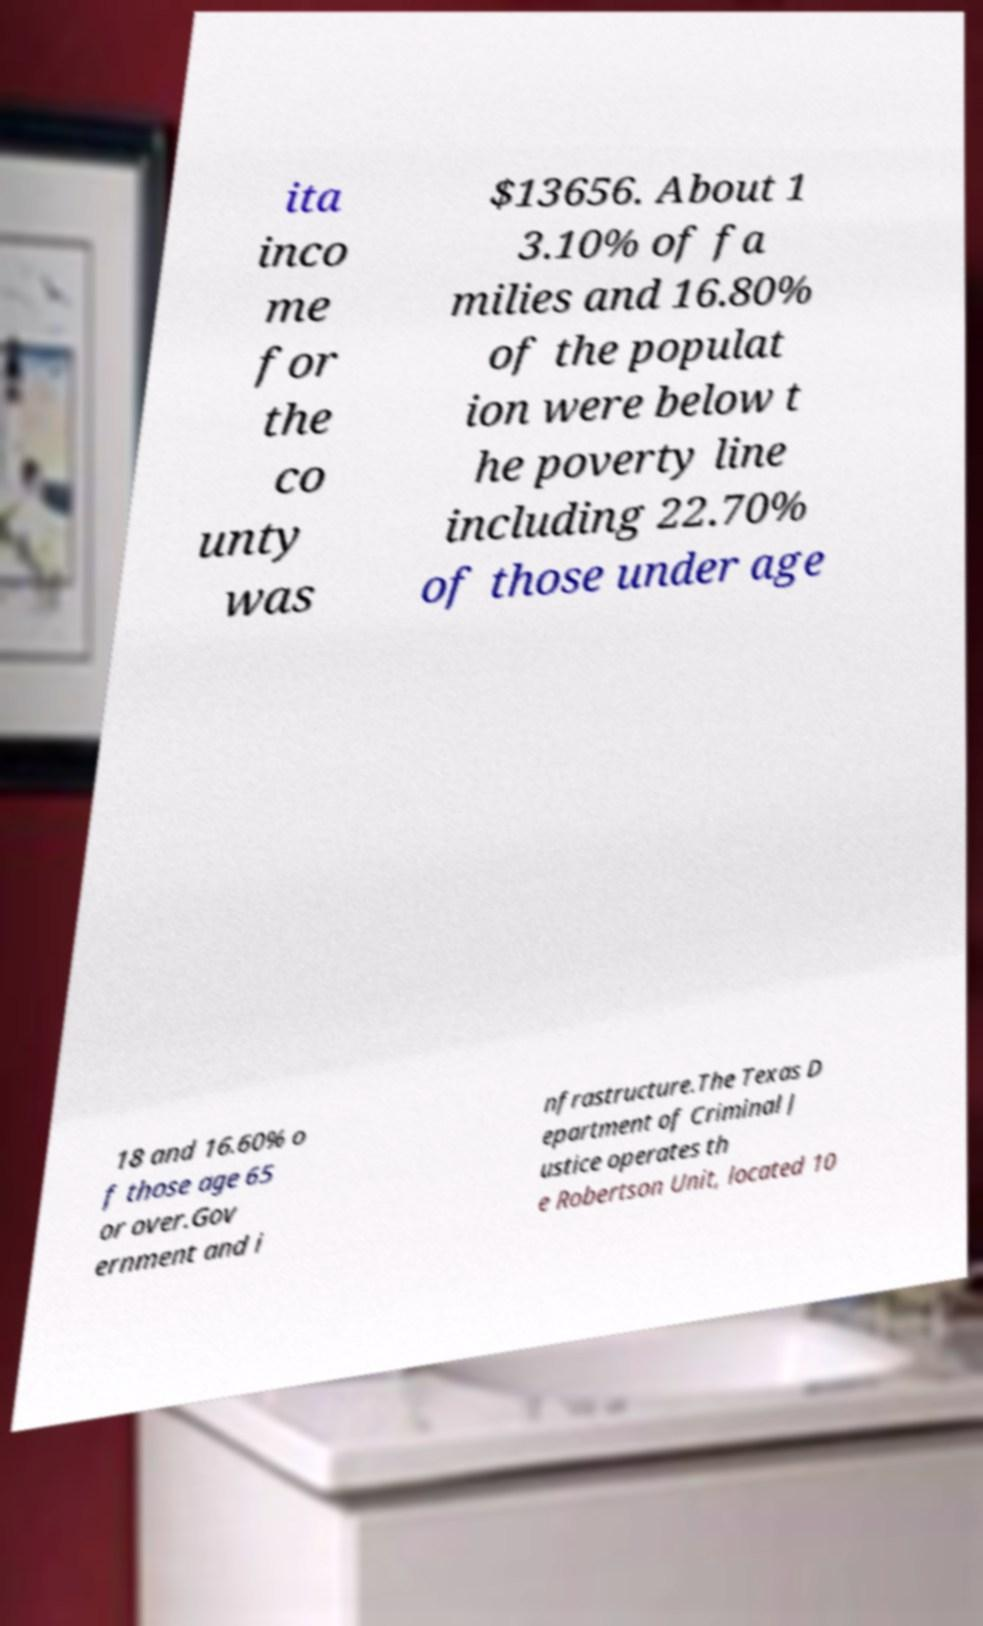Can you read and provide the text displayed in the image?This photo seems to have some interesting text. Can you extract and type it out for me? ita inco me for the co unty was $13656. About 1 3.10% of fa milies and 16.80% of the populat ion were below t he poverty line including 22.70% of those under age 18 and 16.60% o f those age 65 or over.Gov ernment and i nfrastructure.The Texas D epartment of Criminal J ustice operates th e Robertson Unit, located 10 